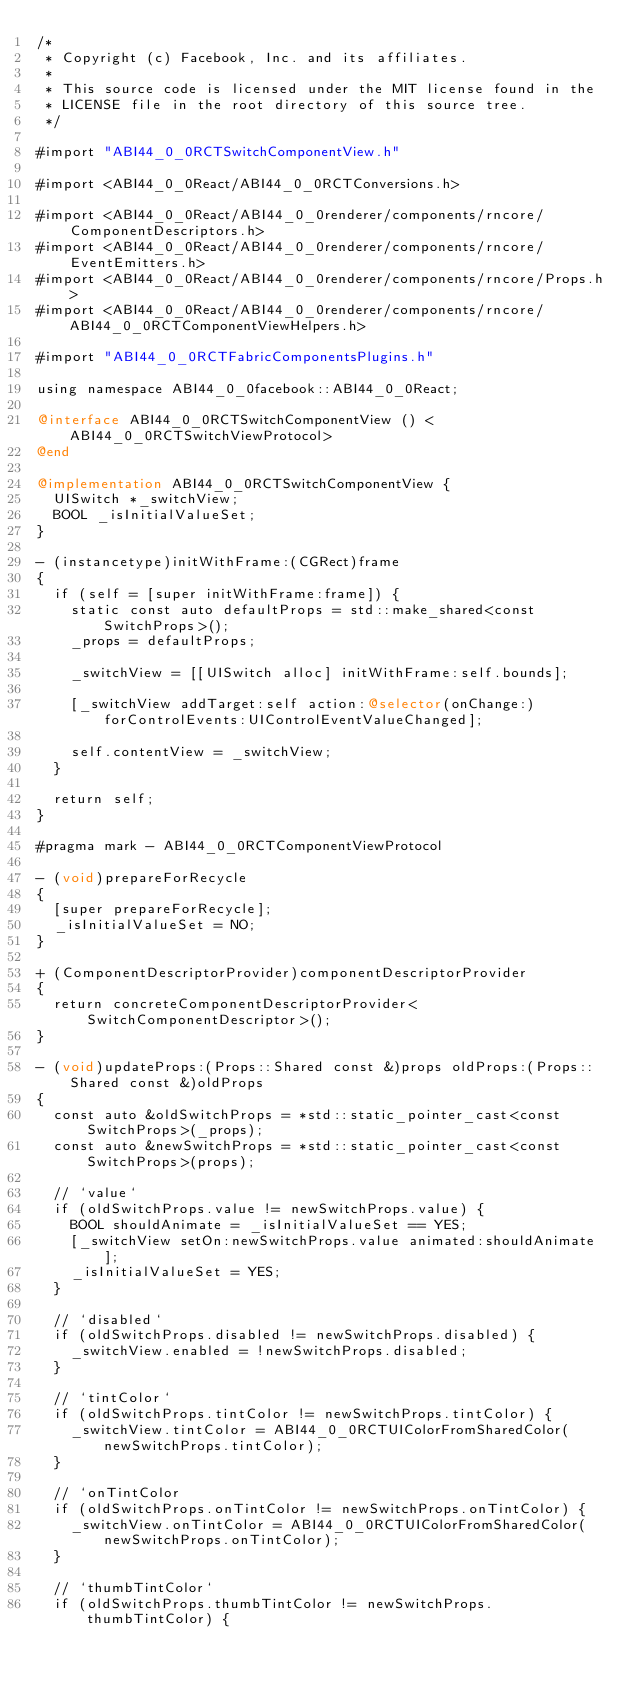Convert code to text. <code><loc_0><loc_0><loc_500><loc_500><_ObjectiveC_>/*
 * Copyright (c) Facebook, Inc. and its affiliates.
 *
 * This source code is licensed under the MIT license found in the
 * LICENSE file in the root directory of this source tree.
 */

#import "ABI44_0_0RCTSwitchComponentView.h"

#import <ABI44_0_0React/ABI44_0_0RCTConversions.h>

#import <ABI44_0_0React/ABI44_0_0renderer/components/rncore/ComponentDescriptors.h>
#import <ABI44_0_0React/ABI44_0_0renderer/components/rncore/EventEmitters.h>
#import <ABI44_0_0React/ABI44_0_0renderer/components/rncore/Props.h>
#import <ABI44_0_0React/ABI44_0_0renderer/components/rncore/ABI44_0_0RCTComponentViewHelpers.h>

#import "ABI44_0_0RCTFabricComponentsPlugins.h"

using namespace ABI44_0_0facebook::ABI44_0_0React;

@interface ABI44_0_0RCTSwitchComponentView () <ABI44_0_0RCTSwitchViewProtocol>
@end

@implementation ABI44_0_0RCTSwitchComponentView {
  UISwitch *_switchView;
  BOOL _isInitialValueSet;
}

- (instancetype)initWithFrame:(CGRect)frame
{
  if (self = [super initWithFrame:frame]) {
    static const auto defaultProps = std::make_shared<const SwitchProps>();
    _props = defaultProps;

    _switchView = [[UISwitch alloc] initWithFrame:self.bounds];

    [_switchView addTarget:self action:@selector(onChange:) forControlEvents:UIControlEventValueChanged];

    self.contentView = _switchView;
  }

  return self;
}

#pragma mark - ABI44_0_0RCTComponentViewProtocol

- (void)prepareForRecycle
{
  [super prepareForRecycle];
  _isInitialValueSet = NO;
}

+ (ComponentDescriptorProvider)componentDescriptorProvider
{
  return concreteComponentDescriptorProvider<SwitchComponentDescriptor>();
}

- (void)updateProps:(Props::Shared const &)props oldProps:(Props::Shared const &)oldProps
{
  const auto &oldSwitchProps = *std::static_pointer_cast<const SwitchProps>(_props);
  const auto &newSwitchProps = *std::static_pointer_cast<const SwitchProps>(props);

  // `value`
  if (oldSwitchProps.value != newSwitchProps.value) {
    BOOL shouldAnimate = _isInitialValueSet == YES;
    [_switchView setOn:newSwitchProps.value animated:shouldAnimate];
    _isInitialValueSet = YES;
  }

  // `disabled`
  if (oldSwitchProps.disabled != newSwitchProps.disabled) {
    _switchView.enabled = !newSwitchProps.disabled;
  }

  // `tintColor`
  if (oldSwitchProps.tintColor != newSwitchProps.tintColor) {
    _switchView.tintColor = ABI44_0_0RCTUIColorFromSharedColor(newSwitchProps.tintColor);
  }

  // `onTintColor
  if (oldSwitchProps.onTintColor != newSwitchProps.onTintColor) {
    _switchView.onTintColor = ABI44_0_0RCTUIColorFromSharedColor(newSwitchProps.onTintColor);
  }

  // `thumbTintColor`
  if (oldSwitchProps.thumbTintColor != newSwitchProps.thumbTintColor) {</code> 